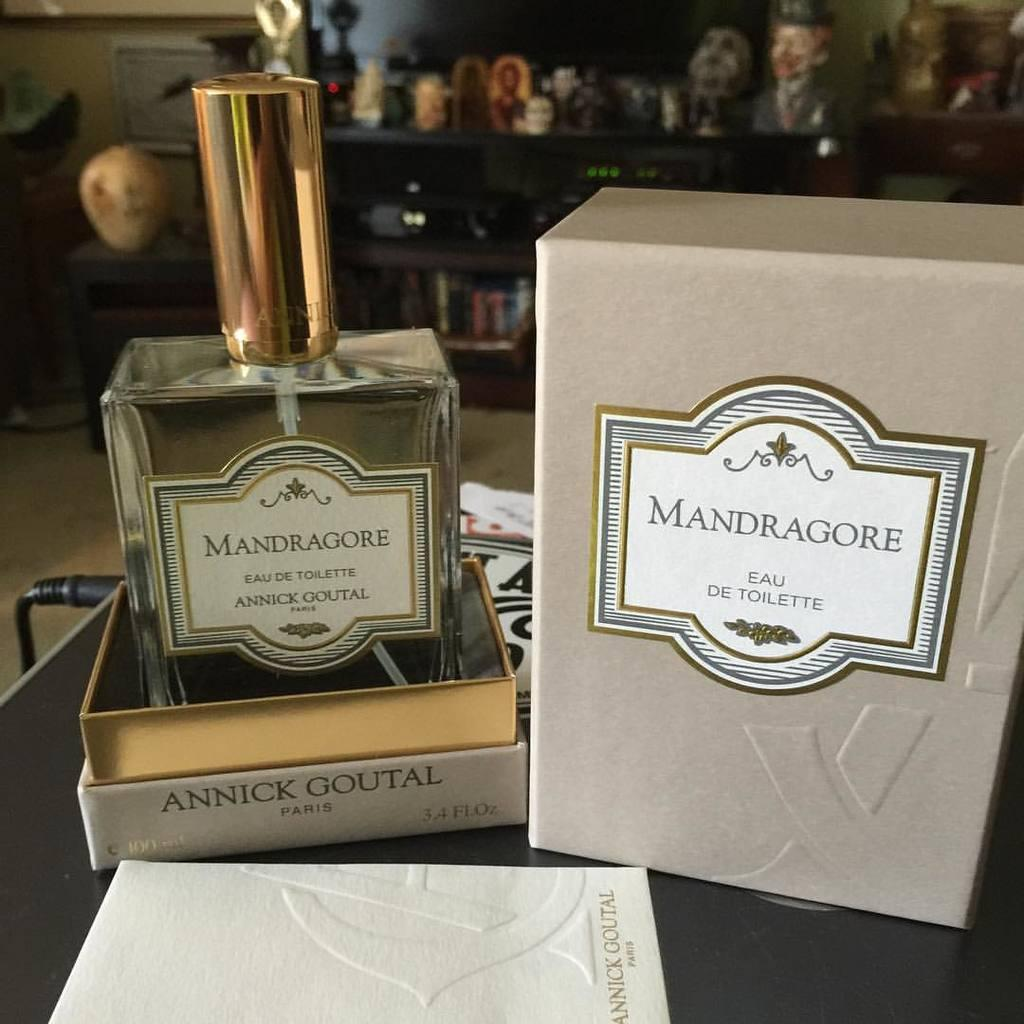<image>
Give a short and clear explanation of the subsequent image. A perfume bottle from ANNICK GOUTAL PARIS with a gold cap. 